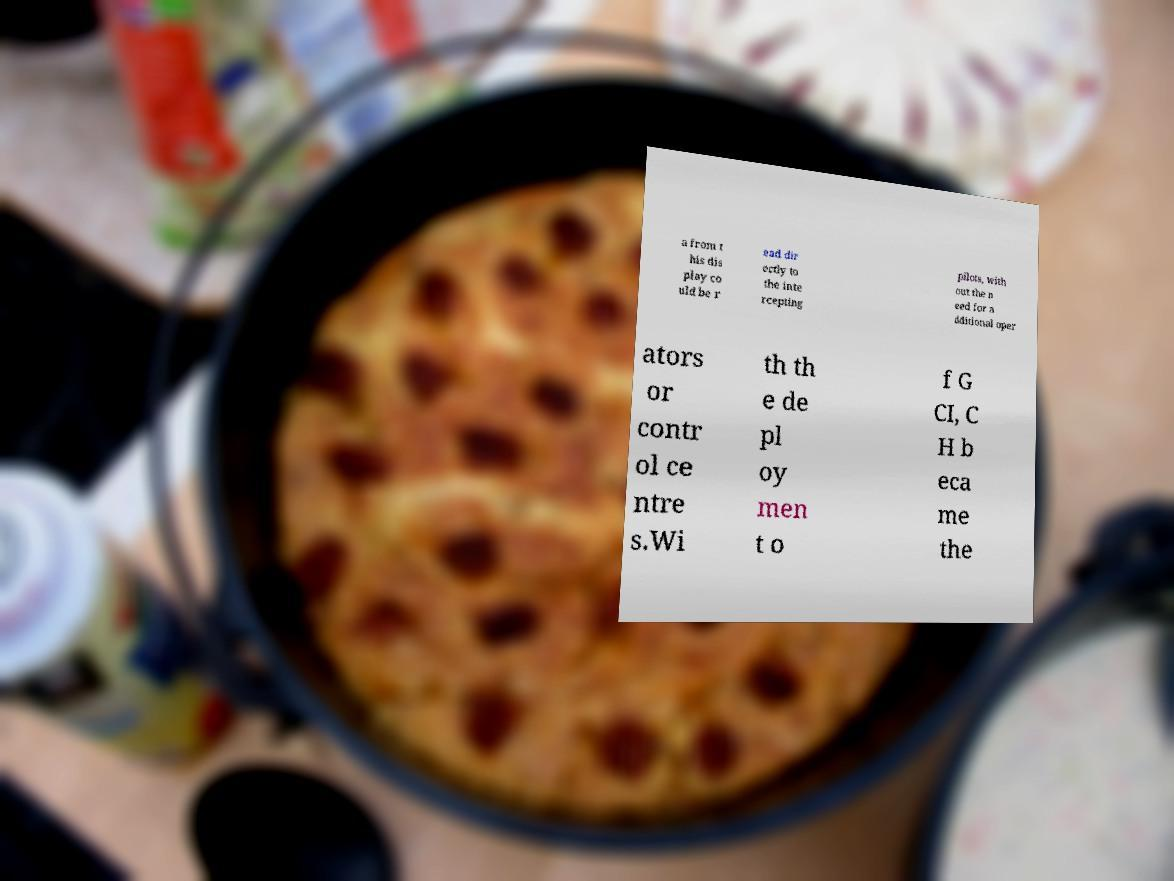Can you read and provide the text displayed in the image?This photo seems to have some interesting text. Can you extract and type it out for me? a from t his dis play co uld be r ead dir ectly to the inte rcepting pilots, with out the n eed for a dditional oper ators or contr ol ce ntre s.Wi th th e de pl oy men t o f G CI, C H b eca me the 